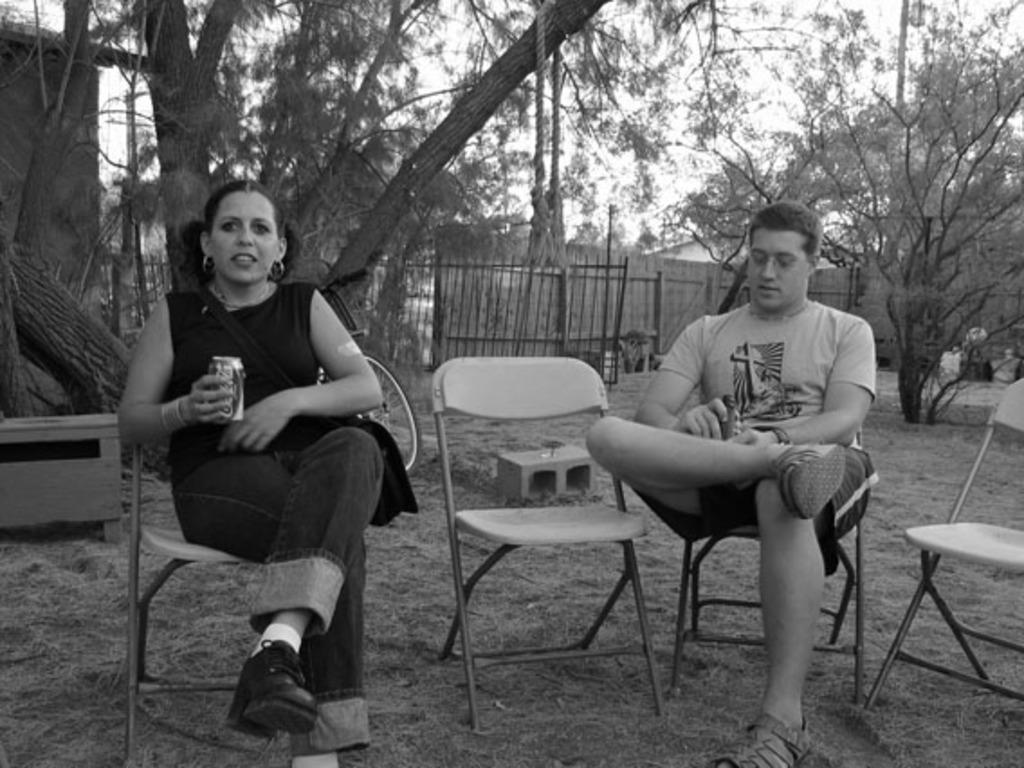Can you describe this image briefly? In this picture there is a woman sitting and holding the tin and there is a man sitting and holding the object and there are chairs. At the back there is a railing and there are trees. On the left side of the image there is a building and there is an object. At the top there is sky. At the bottom there is grass. 